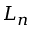<formula> <loc_0><loc_0><loc_500><loc_500>L _ { n }</formula> 